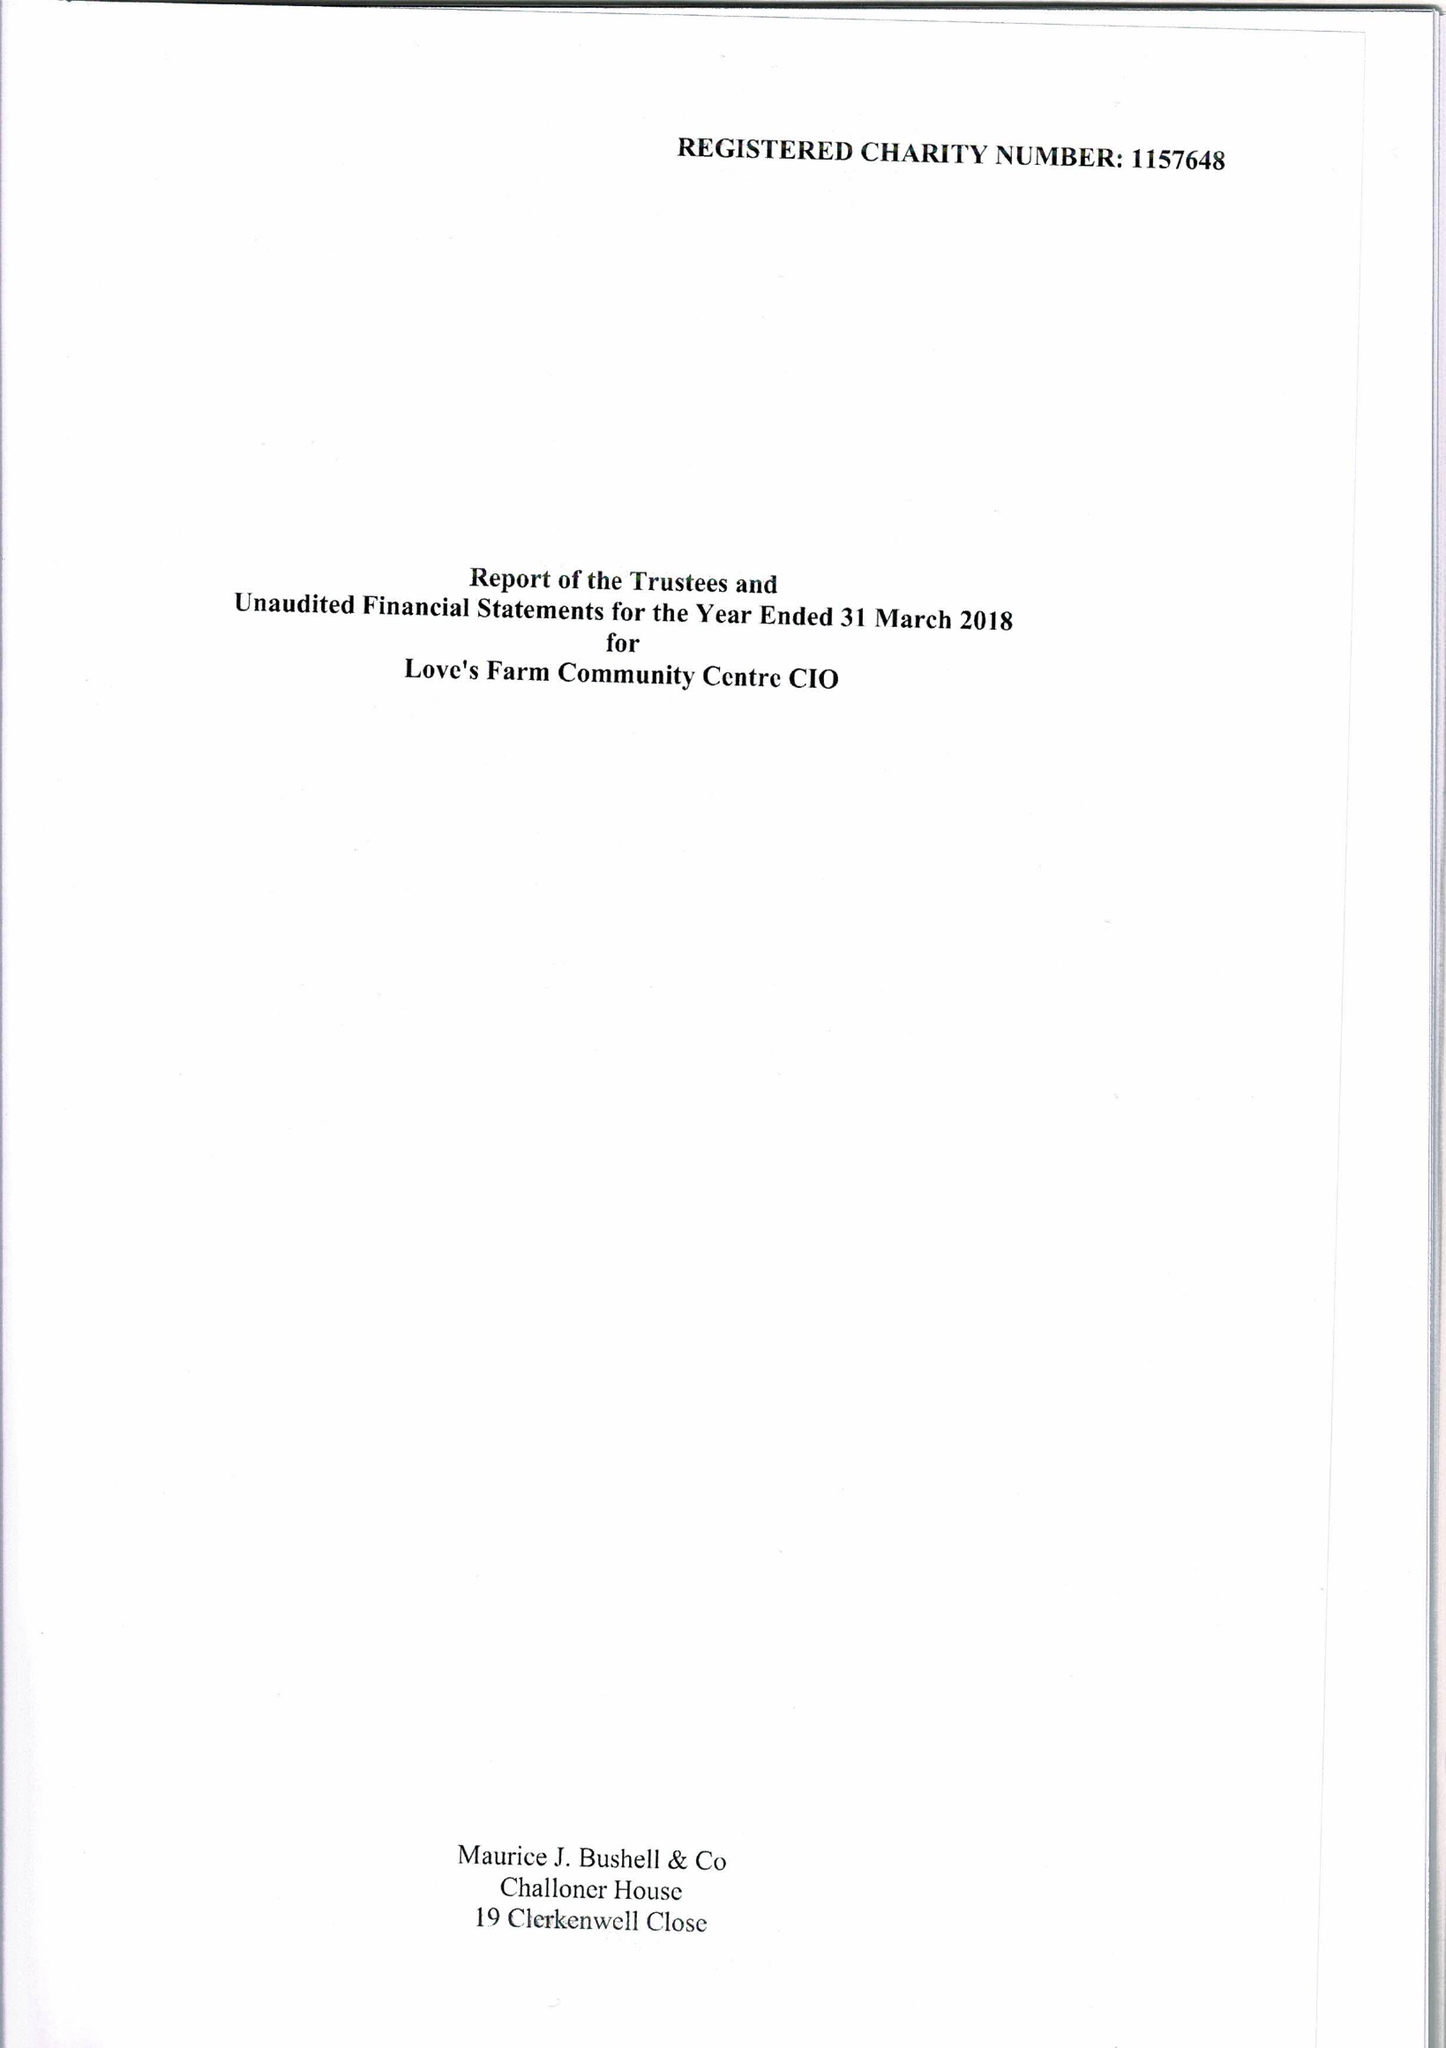What is the value for the charity_name?
Answer the question using a single word or phrase. Love's Farm Community Centre CIO 